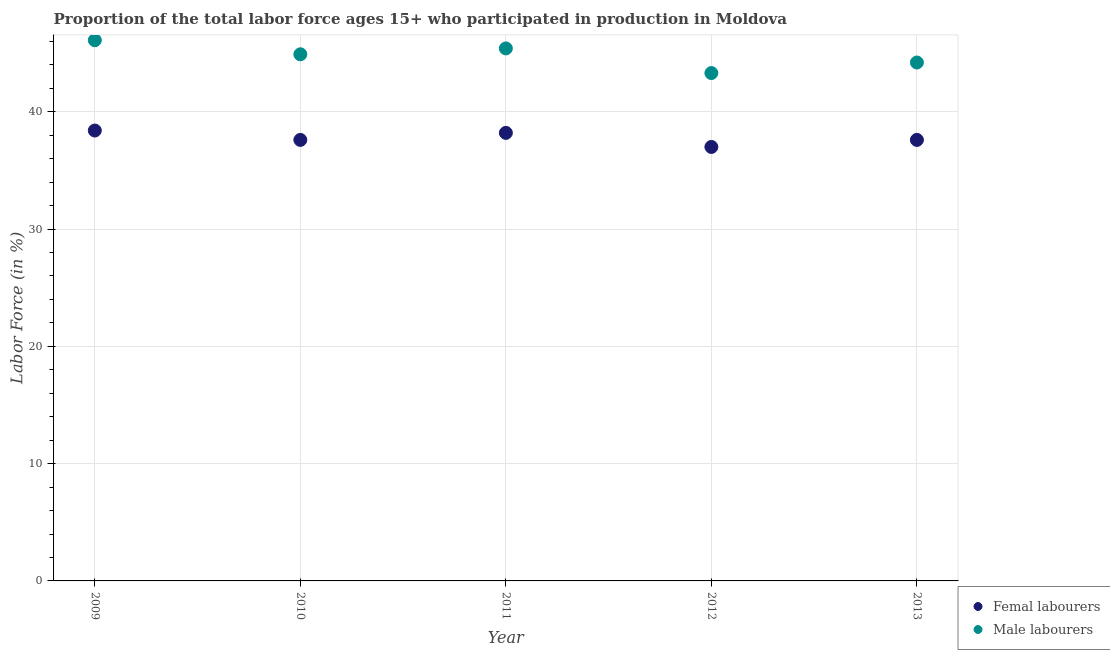Is the number of dotlines equal to the number of legend labels?
Offer a very short reply. Yes. What is the percentage of male labour force in 2011?
Keep it short and to the point. 45.4. Across all years, what is the maximum percentage of female labor force?
Give a very brief answer. 38.4. Across all years, what is the minimum percentage of male labour force?
Ensure brevity in your answer.  43.3. In which year was the percentage of male labour force maximum?
Your answer should be compact. 2009. In which year was the percentage of female labor force minimum?
Your answer should be very brief. 2012. What is the total percentage of female labor force in the graph?
Offer a terse response. 188.8. What is the difference between the percentage of male labour force in 2011 and that in 2012?
Provide a short and direct response. 2.1. What is the difference between the percentage of female labor force in 2011 and the percentage of male labour force in 2013?
Provide a short and direct response. -6. What is the average percentage of male labour force per year?
Keep it short and to the point. 44.78. In the year 2013, what is the difference between the percentage of male labour force and percentage of female labor force?
Offer a terse response. 6.6. In how many years, is the percentage of female labor force greater than 18 %?
Make the answer very short. 5. What is the ratio of the percentage of female labor force in 2010 to that in 2011?
Make the answer very short. 0.98. What is the difference between the highest and the second highest percentage of male labour force?
Keep it short and to the point. 0.7. What is the difference between the highest and the lowest percentage of female labor force?
Ensure brevity in your answer.  1.4. In how many years, is the percentage of male labour force greater than the average percentage of male labour force taken over all years?
Keep it short and to the point. 3. Is the percentage of female labor force strictly greater than the percentage of male labour force over the years?
Make the answer very short. No. Is the percentage of male labour force strictly less than the percentage of female labor force over the years?
Provide a short and direct response. No. How many years are there in the graph?
Your response must be concise. 5. Are the values on the major ticks of Y-axis written in scientific E-notation?
Ensure brevity in your answer.  No. Does the graph contain any zero values?
Make the answer very short. No. Where does the legend appear in the graph?
Your response must be concise. Bottom right. How many legend labels are there?
Provide a short and direct response. 2. What is the title of the graph?
Your answer should be compact. Proportion of the total labor force ages 15+ who participated in production in Moldova. What is the label or title of the X-axis?
Offer a terse response. Year. What is the Labor Force (in %) of Femal labourers in 2009?
Your answer should be very brief. 38.4. What is the Labor Force (in %) in Male labourers in 2009?
Make the answer very short. 46.1. What is the Labor Force (in %) in Femal labourers in 2010?
Offer a terse response. 37.6. What is the Labor Force (in %) of Male labourers in 2010?
Keep it short and to the point. 44.9. What is the Labor Force (in %) of Femal labourers in 2011?
Give a very brief answer. 38.2. What is the Labor Force (in %) in Male labourers in 2011?
Your answer should be compact. 45.4. What is the Labor Force (in %) in Male labourers in 2012?
Provide a succinct answer. 43.3. What is the Labor Force (in %) in Femal labourers in 2013?
Offer a terse response. 37.6. What is the Labor Force (in %) of Male labourers in 2013?
Ensure brevity in your answer.  44.2. Across all years, what is the maximum Labor Force (in %) of Femal labourers?
Make the answer very short. 38.4. Across all years, what is the maximum Labor Force (in %) of Male labourers?
Offer a very short reply. 46.1. Across all years, what is the minimum Labor Force (in %) in Male labourers?
Offer a very short reply. 43.3. What is the total Labor Force (in %) in Femal labourers in the graph?
Ensure brevity in your answer.  188.8. What is the total Labor Force (in %) of Male labourers in the graph?
Offer a very short reply. 223.9. What is the difference between the Labor Force (in %) of Femal labourers in 2009 and that in 2011?
Make the answer very short. 0.2. What is the difference between the Labor Force (in %) of Femal labourers in 2009 and that in 2012?
Your response must be concise. 1.4. What is the difference between the Labor Force (in %) in Male labourers in 2010 and that in 2011?
Offer a very short reply. -0.5. What is the difference between the Labor Force (in %) in Male labourers in 2010 and that in 2012?
Provide a succinct answer. 1.6. What is the difference between the Labor Force (in %) in Femal labourers in 2010 and that in 2013?
Your response must be concise. 0. What is the difference between the Labor Force (in %) of Male labourers in 2010 and that in 2013?
Keep it short and to the point. 0.7. What is the difference between the Labor Force (in %) in Male labourers in 2011 and that in 2012?
Provide a short and direct response. 2.1. What is the difference between the Labor Force (in %) in Femal labourers in 2011 and that in 2013?
Your answer should be compact. 0.6. What is the difference between the Labor Force (in %) in Male labourers in 2011 and that in 2013?
Provide a succinct answer. 1.2. What is the difference between the Labor Force (in %) in Femal labourers in 2012 and that in 2013?
Provide a short and direct response. -0.6. What is the difference between the Labor Force (in %) of Male labourers in 2012 and that in 2013?
Your answer should be compact. -0.9. What is the difference between the Labor Force (in %) in Femal labourers in 2009 and the Labor Force (in %) in Male labourers in 2011?
Give a very brief answer. -7. What is the difference between the Labor Force (in %) in Femal labourers in 2009 and the Labor Force (in %) in Male labourers in 2012?
Your answer should be compact. -4.9. What is the difference between the Labor Force (in %) in Femal labourers in 2009 and the Labor Force (in %) in Male labourers in 2013?
Ensure brevity in your answer.  -5.8. What is the difference between the Labor Force (in %) of Femal labourers in 2010 and the Labor Force (in %) of Male labourers in 2011?
Give a very brief answer. -7.8. What is the difference between the Labor Force (in %) in Femal labourers in 2010 and the Labor Force (in %) in Male labourers in 2013?
Ensure brevity in your answer.  -6.6. What is the difference between the Labor Force (in %) of Femal labourers in 2011 and the Labor Force (in %) of Male labourers in 2012?
Your response must be concise. -5.1. What is the difference between the Labor Force (in %) of Femal labourers in 2011 and the Labor Force (in %) of Male labourers in 2013?
Your answer should be compact. -6. What is the average Labor Force (in %) of Femal labourers per year?
Keep it short and to the point. 37.76. What is the average Labor Force (in %) in Male labourers per year?
Ensure brevity in your answer.  44.78. In the year 2010, what is the difference between the Labor Force (in %) in Femal labourers and Labor Force (in %) in Male labourers?
Keep it short and to the point. -7.3. In the year 2011, what is the difference between the Labor Force (in %) of Femal labourers and Labor Force (in %) of Male labourers?
Make the answer very short. -7.2. In the year 2013, what is the difference between the Labor Force (in %) of Femal labourers and Labor Force (in %) of Male labourers?
Make the answer very short. -6.6. What is the ratio of the Labor Force (in %) in Femal labourers in 2009 to that in 2010?
Offer a terse response. 1.02. What is the ratio of the Labor Force (in %) of Male labourers in 2009 to that in 2010?
Ensure brevity in your answer.  1.03. What is the ratio of the Labor Force (in %) in Male labourers in 2009 to that in 2011?
Ensure brevity in your answer.  1.02. What is the ratio of the Labor Force (in %) in Femal labourers in 2009 to that in 2012?
Your answer should be very brief. 1.04. What is the ratio of the Labor Force (in %) of Male labourers in 2009 to that in 2012?
Provide a succinct answer. 1.06. What is the ratio of the Labor Force (in %) in Femal labourers in 2009 to that in 2013?
Ensure brevity in your answer.  1.02. What is the ratio of the Labor Force (in %) in Male labourers in 2009 to that in 2013?
Make the answer very short. 1.04. What is the ratio of the Labor Force (in %) in Femal labourers in 2010 to that in 2011?
Offer a terse response. 0.98. What is the ratio of the Labor Force (in %) of Male labourers in 2010 to that in 2011?
Make the answer very short. 0.99. What is the ratio of the Labor Force (in %) of Femal labourers in 2010 to that in 2012?
Give a very brief answer. 1.02. What is the ratio of the Labor Force (in %) of Male labourers in 2010 to that in 2012?
Provide a short and direct response. 1.04. What is the ratio of the Labor Force (in %) of Femal labourers in 2010 to that in 2013?
Ensure brevity in your answer.  1. What is the ratio of the Labor Force (in %) of Male labourers in 2010 to that in 2013?
Your answer should be very brief. 1.02. What is the ratio of the Labor Force (in %) in Femal labourers in 2011 to that in 2012?
Ensure brevity in your answer.  1.03. What is the ratio of the Labor Force (in %) in Male labourers in 2011 to that in 2012?
Make the answer very short. 1.05. What is the ratio of the Labor Force (in %) of Male labourers in 2011 to that in 2013?
Your answer should be very brief. 1.03. What is the ratio of the Labor Force (in %) of Male labourers in 2012 to that in 2013?
Provide a succinct answer. 0.98. What is the difference between the highest and the second highest Labor Force (in %) of Femal labourers?
Provide a succinct answer. 0.2. 